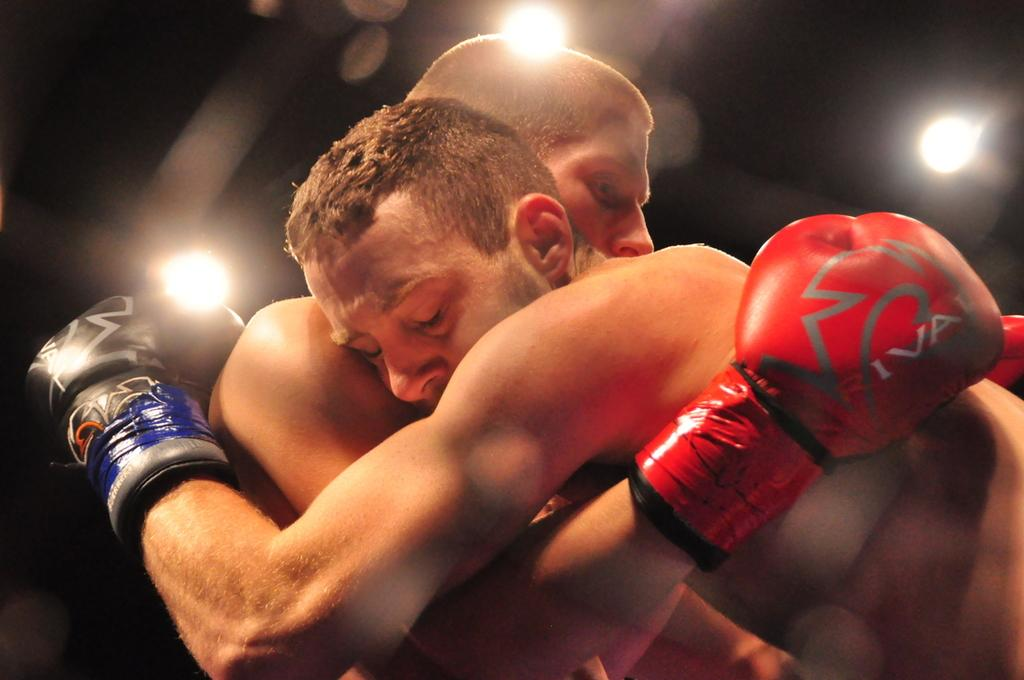How many people are in the image? There are two persons in the image. What are the two persons doing in the image? The two persons are hugging each other. What can be seen in the image besides the two persons? There are lights visible in the image. What is the color of the background in the image? The background of the image is dark. What type of cushion can be seen on the floor in the image? There is no cushion present on the floor in the image. How does the comb help the two persons in the image? There is no comb present in the image, so it cannot help the two persons. 